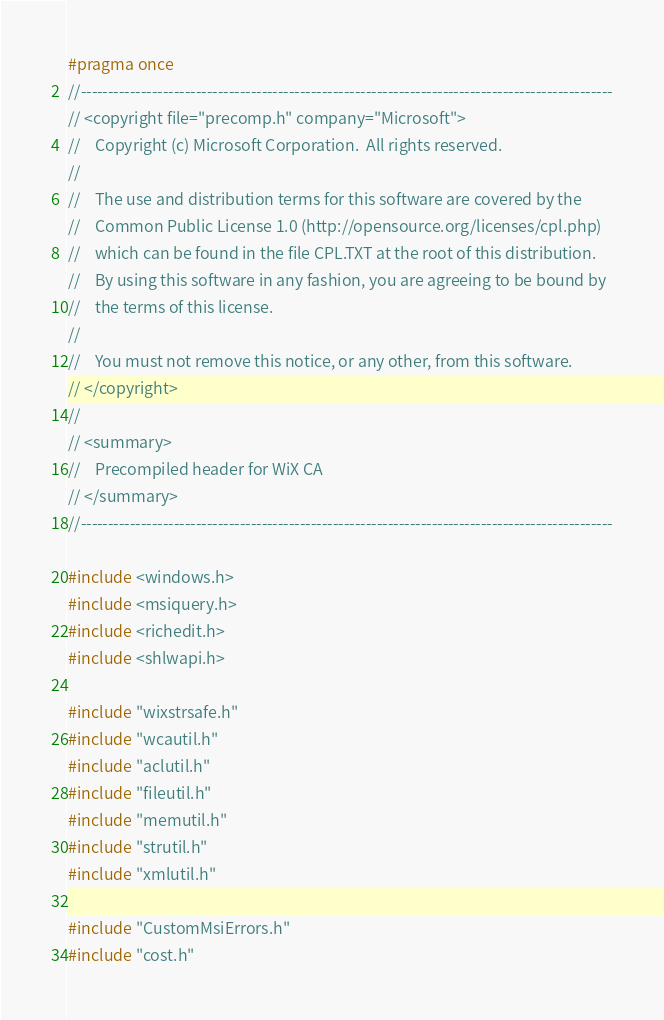Convert code to text. <code><loc_0><loc_0><loc_500><loc_500><_C_>#pragma once
//-------------------------------------------------------------------------------------------------
// <copyright file="precomp.h" company="Microsoft">
//    Copyright (c) Microsoft Corporation.  All rights reserved.
//    
//    The use and distribution terms for this software are covered by the
//    Common Public License 1.0 (http://opensource.org/licenses/cpl.php)
//    which can be found in the file CPL.TXT at the root of this distribution.
//    By using this software in any fashion, you are agreeing to be bound by
//    the terms of this license.
//    
//    You must not remove this notice, or any other, from this software.
// </copyright>
// 
// <summary>
//    Precompiled header for WiX CA
// </summary>
//-------------------------------------------------------------------------------------------------

#include <windows.h>
#include <msiquery.h>
#include <richedit.h>
#include <shlwapi.h>

#include "wixstrsafe.h"
#include "wcautil.h"
#include "aclutil.h"
#include "fileutil.h"
#include "memutil.h"
#include "strutil.h"
#include "xmlutil.h"

#include "CustomMsiErrors.h"
#include "cost.h"
</code> 